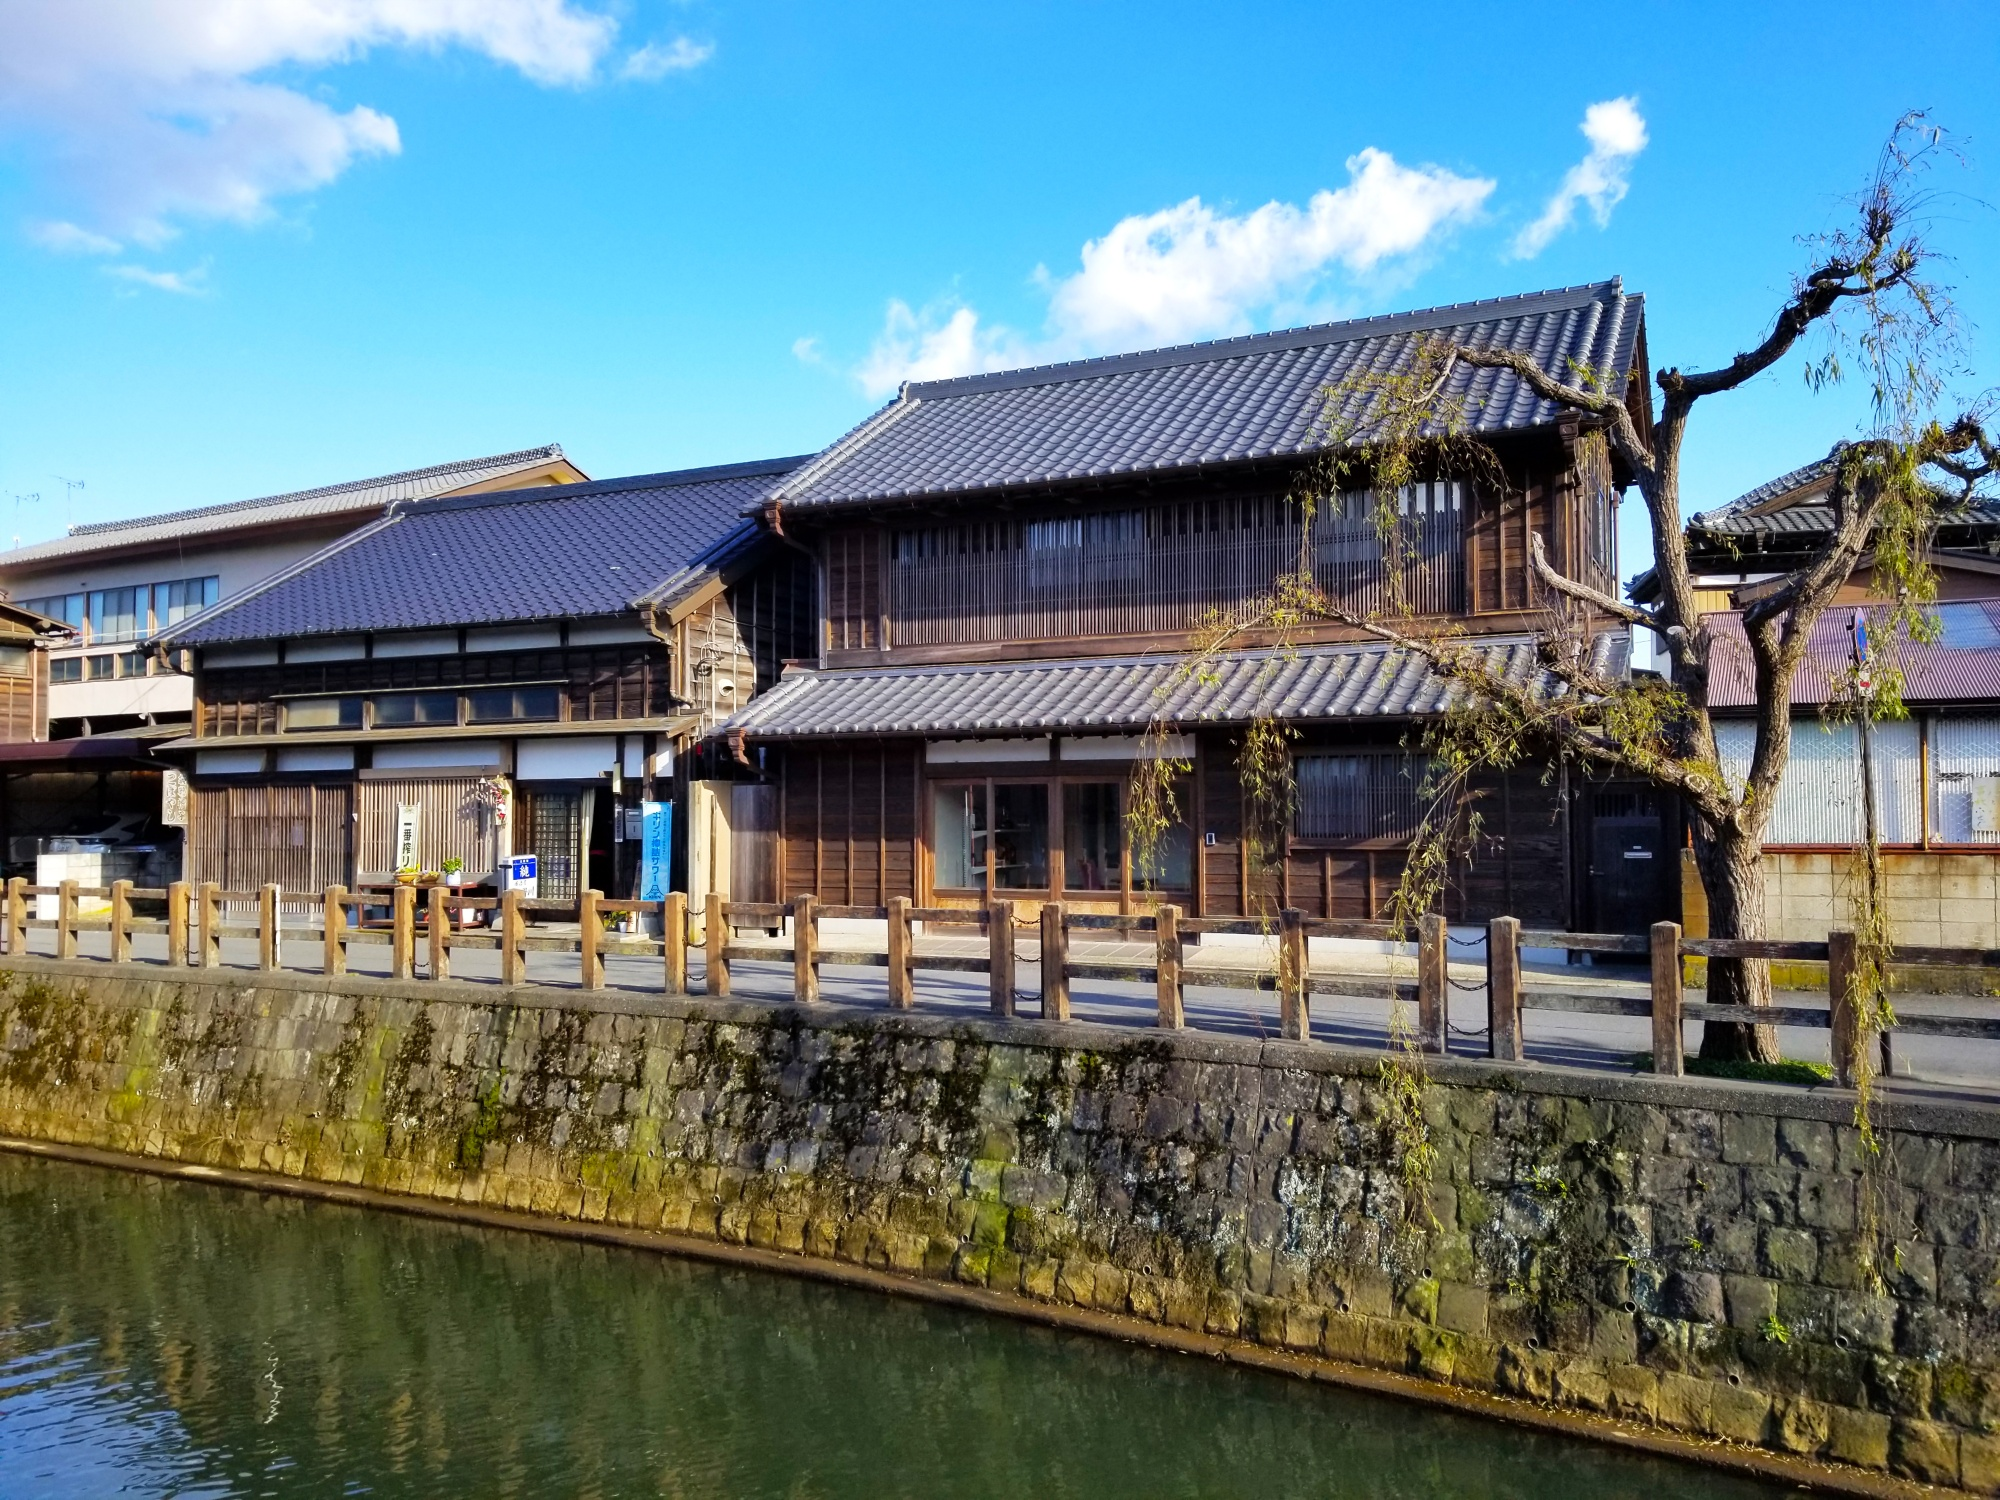Can you tell me more about the architecture style of the buildings in this image? The buildings in the image represent a traditional Japanese architectural style known as 'machiya.' These are townhouses or shop houses that are typical in historic Japanese neighborhoods, often found in Kyoto. Machiya feature wooden structures with tiled roofs, sliding doors, and wooden lattices over windows, characteristic of Japanese craftsmanship. They are designed to accommodate both residential and commercial activities, reflecting a functional blend of living and working spaces. 